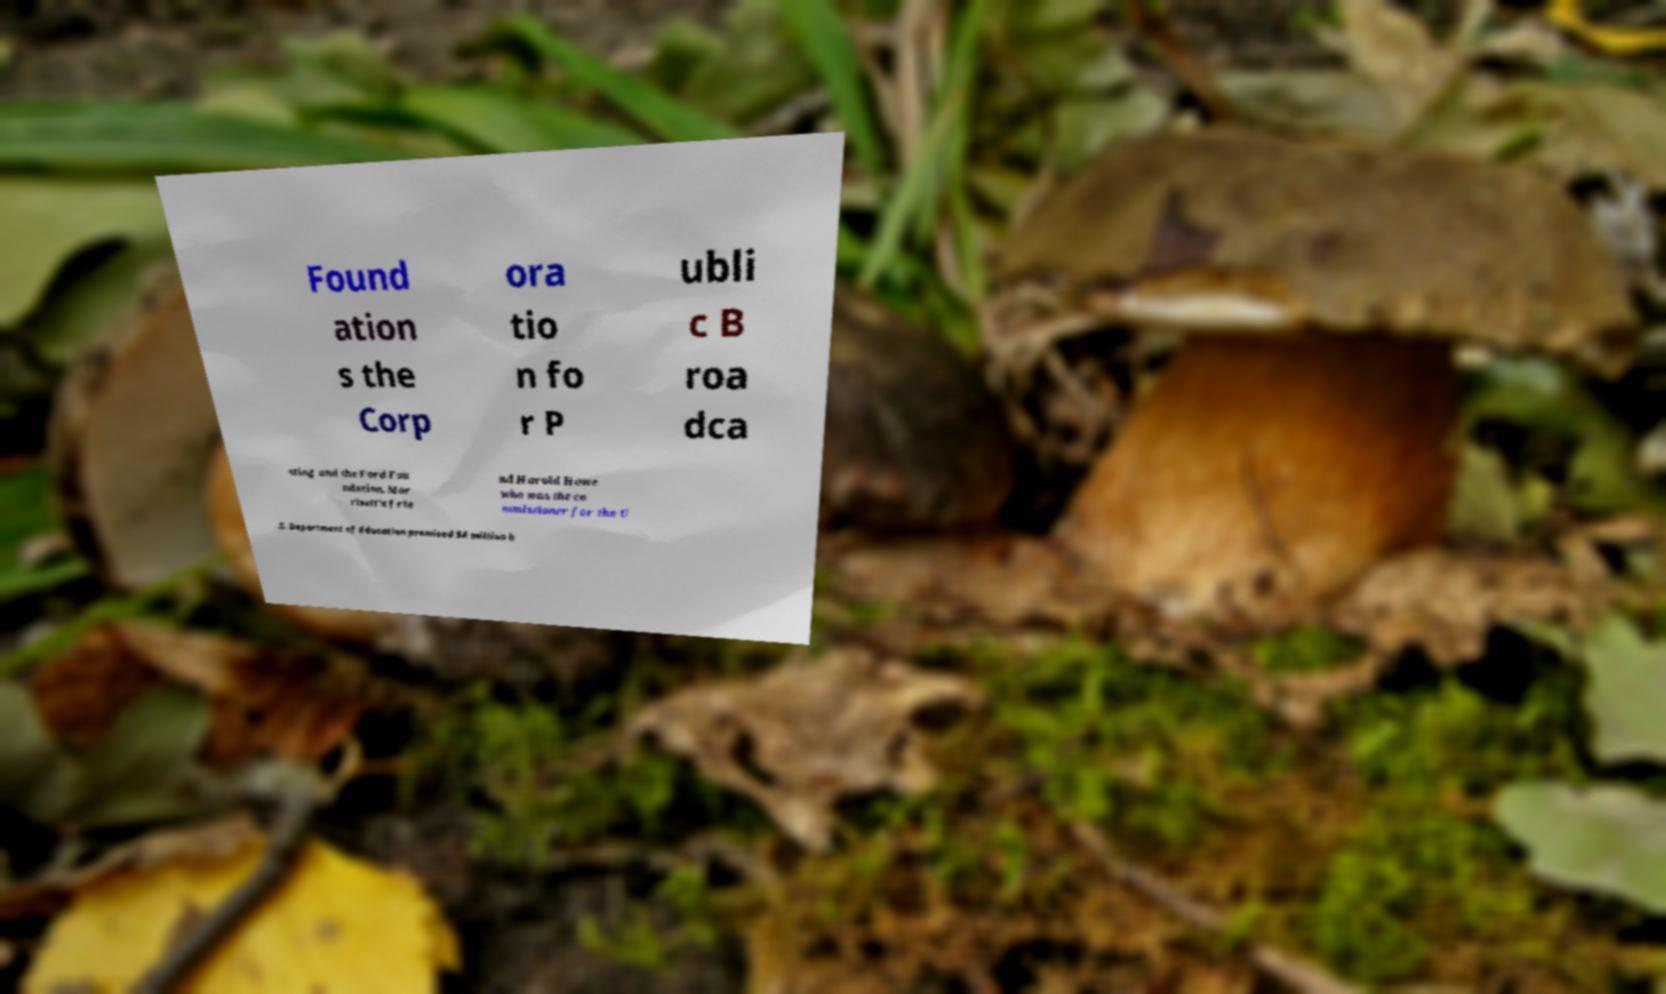What messages or text are displayed in this image? I need them in a readable, typed format. Found ation s the Corp ora tio n fo r P ubli c B roa dca sting and the Ford Fou ndation. Mor risett's frie nd Harold Howe who was the co mmissioner for the U .S. Department of Education promised $4 million h 